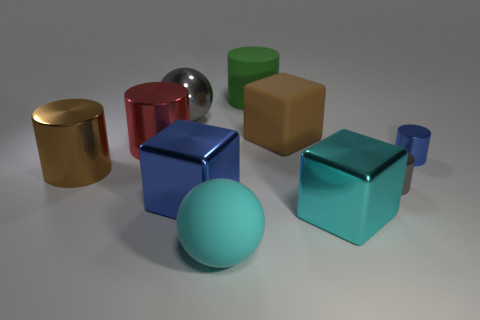How many yellow objects are big shiny cylinders or matte cylinders?
Ensure brevity in your answer.  0. There is a blue cylinder right of the big brown shiny cylinder; what material is it?
Offer a very short reply. Metal. How many big metallic objects are to the right of the blue object that is in front of the gray cylinder?
Your response must be concise. 1. What number of tiny green metal things are the same shape as the cyan metal object?
Provide a succinct answer. 0. How many large gray cylinders are there?
Ensure brevity in your answer.  0. There is a large thing left of the red thing; what color is it?
Your response must be concise. Brown. There is a large sphere in front of the gray sphere behind the big blue metallic block; what color is it?
Provide a succinct answer. Cyan. The other shiny cube that is the same size as the cyan shiny cube is what color?
Give a very brief answer. Blue. How many things are both in front of the tiny blue metal object and to the right of the big brown block?
Make the answer very short. 2. There is a large shiny thing that is the same color as the matte block; what shape is it?
Offer a terse response. Cylinder. 